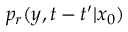<formula> <loc_0><loc_0><loc_500><loc_500>p _ { r } ( y , t - t ^ { \prime } | x _ { 0 } )</formula> 